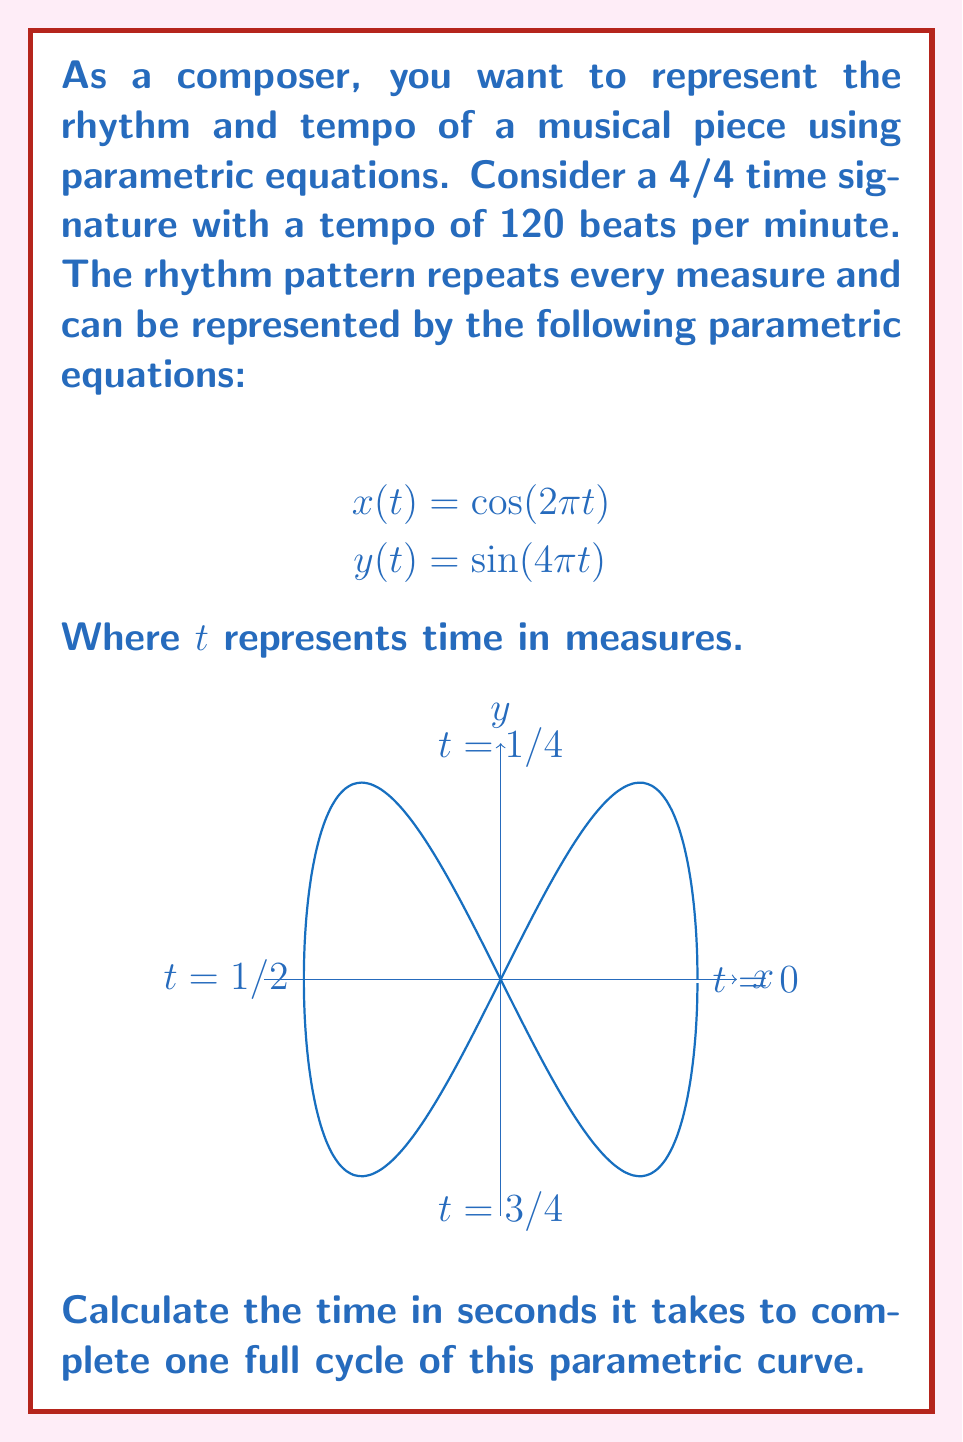Can you solve this math problem? Let's approach this step-by-step:

1) First, we need to understand what one full cycle means in this context. Looking at the equations:

   $$x(t) = \cos(2\pi t)$$
   $$y(t) = \sin(4\pi t)$$

   The $x$ component completes one full cycle when $2\pi t = 2\pi$, or when $t = 1$.
   The $y$ component completes two full cycles in the same period.

2) So, one full cycle of the parametric curve corresponds to $t = 1$ measure.

3) Now, we need to convert this to seconds. We're given that the tempo is 120 beats per minute, and we have a 4/4 time signature.

4) In 4/4 time, there are 4 beats per measure. So:

   120 beats/minute = 30 measures/minute

5) To find how many seconds are in one measure:

   $$\frac{60 \text{ seconds}}{30 \text{ measures}} = 2 \text{ seconds/measure}$$

6) Since one full cycle of our parametric curve takes 1 measure, and 1 measure takes 2 seconds, the time to complete one full cycle is 2 seconds.
Answer: 2 seconds 